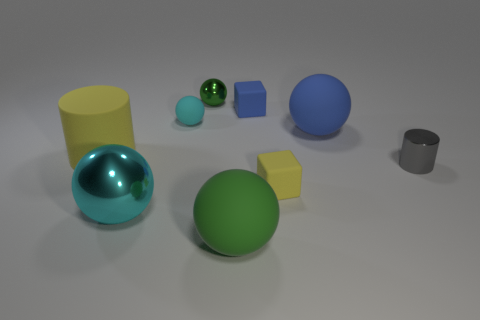Subtract 2 spheres. How many spheres are left? 3 Subtract all blue spheres. How many spheres are left? 4 Subtract all blue matte balls. How many balls are left? 4 Subtract all red balls. Subtract all blue cylinders. How many balls are left? 5 Add 1 blue rubber spheres. How many objects exist? 10 Subtract all cylinders. How many objects are left? 7 Add 1 brown objects. How many brown objects exist? 1 Subtract 2 cyan balls. How many objects are left? 7 Subtract all large blue matte objects. Subtract all small gray metal cylinders. How many objects are left? 7 Add 4 large metallic balls. How many large metallic balls are left? 5 